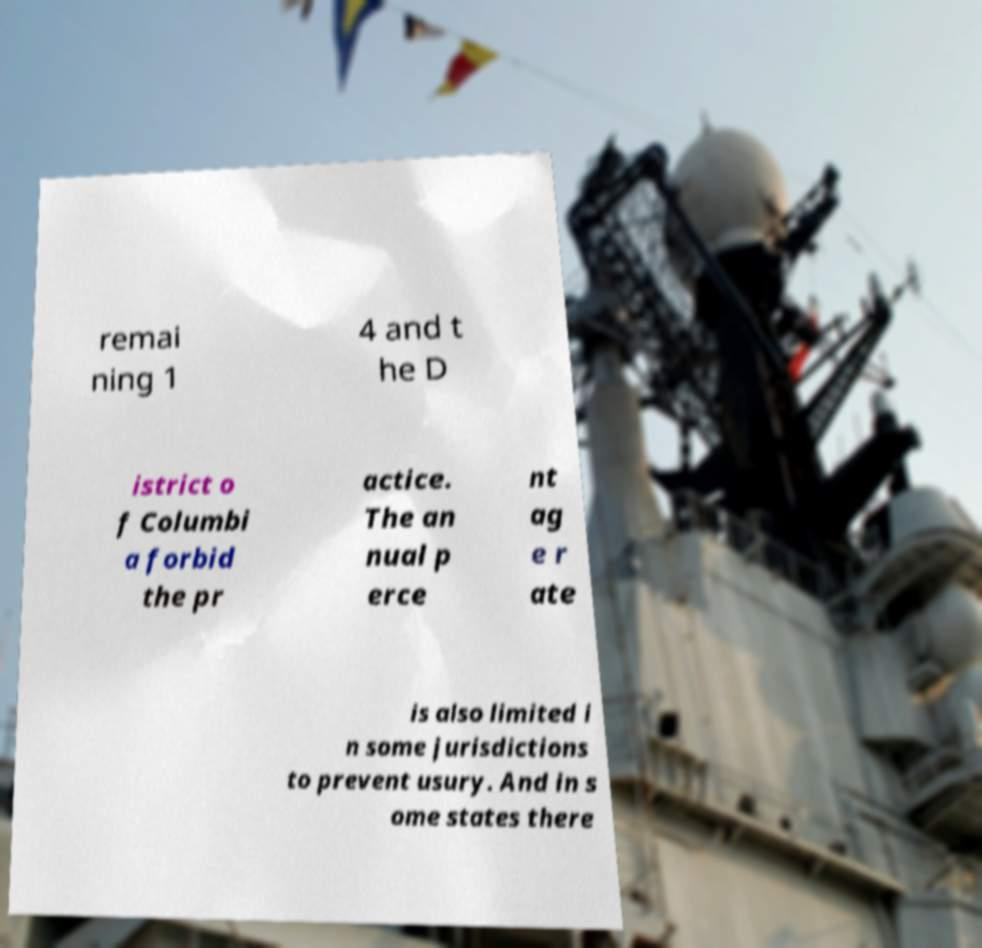There's text embedded in this image that I need extracted. Can you transcribe it verbatim? remai ning 1 4 and t he D istrict o f Columbi a forbid the pr actice. The an nual p erce nt ag e r ate is also limited i n some jurisdictions to prevent usury. And in s ome states there 